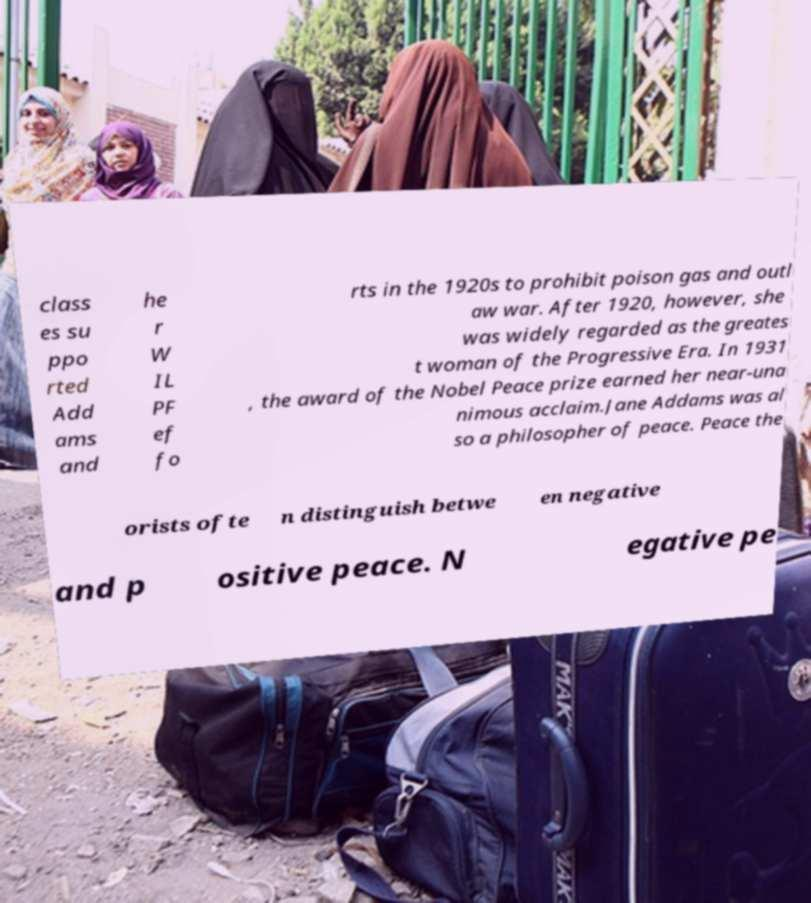Can you read and provide the text displayed in the image?This photo seems to have some interesting text. Can you extract and type it out for me? class es su ppo rted Add ams and he r W IL PF ef fo rts in the 1920s to prohibit poison gas and outl aw war. After 1920, however, she was widely regarded as the greates t woman of the Progressive Era. In 1931 , the award of the Nobel Peace prize earned her near-una nimous acclaim.Jane Addams was al so a philosopher of peace. Peace the orists ofte n distinguish betwe en negative and p ositive peace. N egative pe 